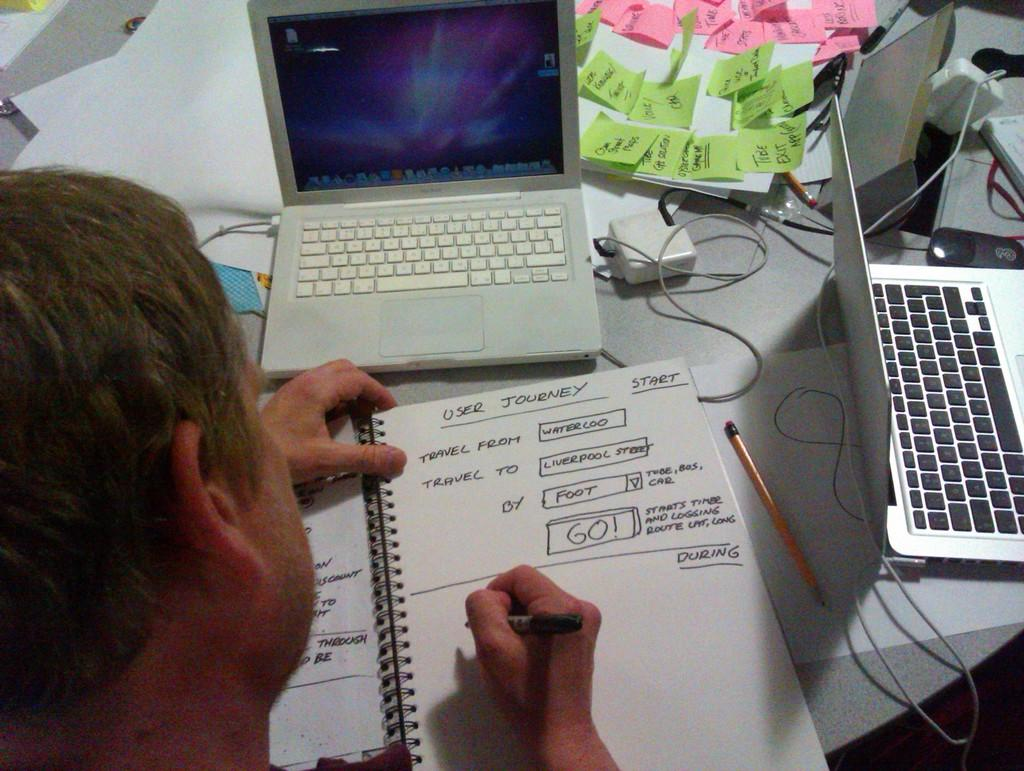Provide a one-sentence caption for the provided image. A man writing in a book titled user journey. 